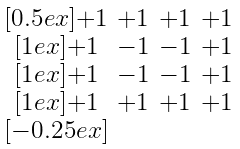<formula> <loc_0><loc_0><loc_500><loc_500>\begin{smallmatrix} & & & \\ [ 0 . 5 e x ] + 1 & + 1 & + 1 & + 1 \\ [ 1 e x ] + 1 & - 1 & - 1 & + 1 \\ [ 1 e x ] + 1 & - 1 & - 1 & + 1 \\ [ 1 e x ] + 1 & + 1 & + 1 & + 1 \\ [ - 0 . 2 5 e x ] & & & \end{smallmatrix}</formula> 